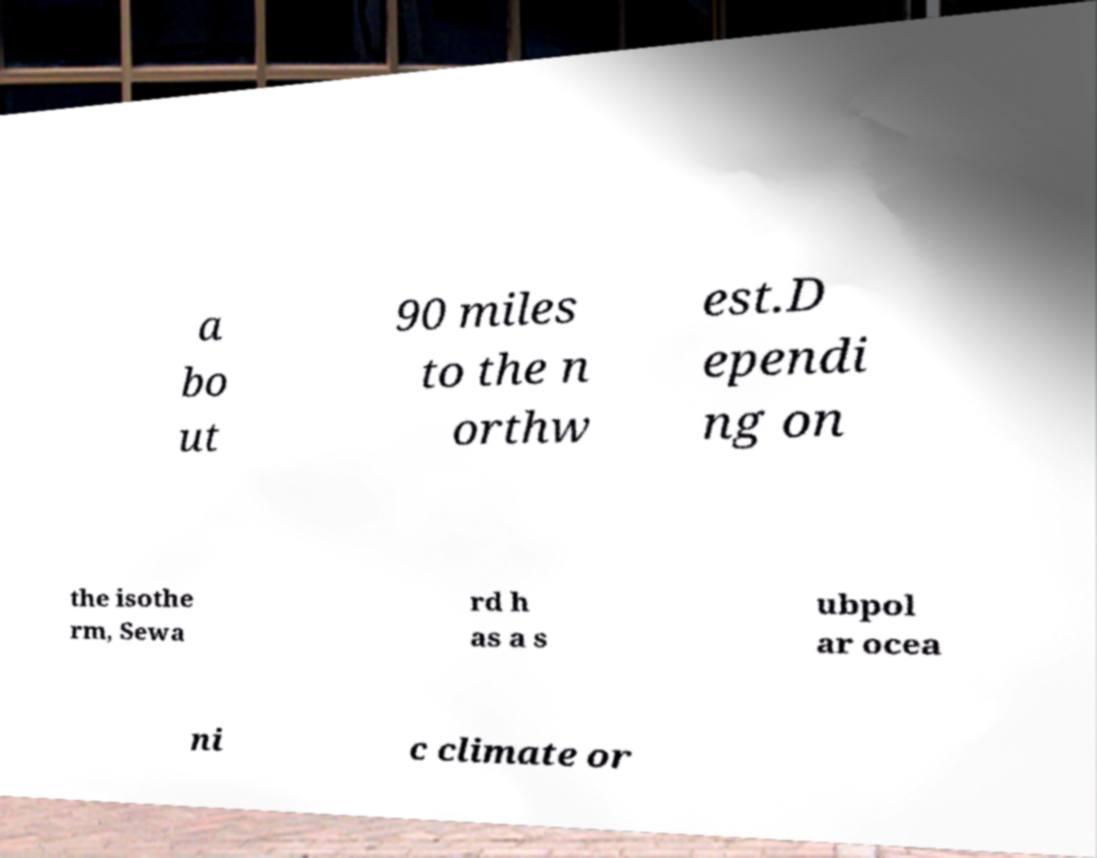For documentation purposes, I need the text within this image transcribed. Could you provide that? a bo ut 90 miles to the n orthw est.D ependi ng on the isothe rm, Sewa rd h as a s ubpol ar ocea ni c climate or 